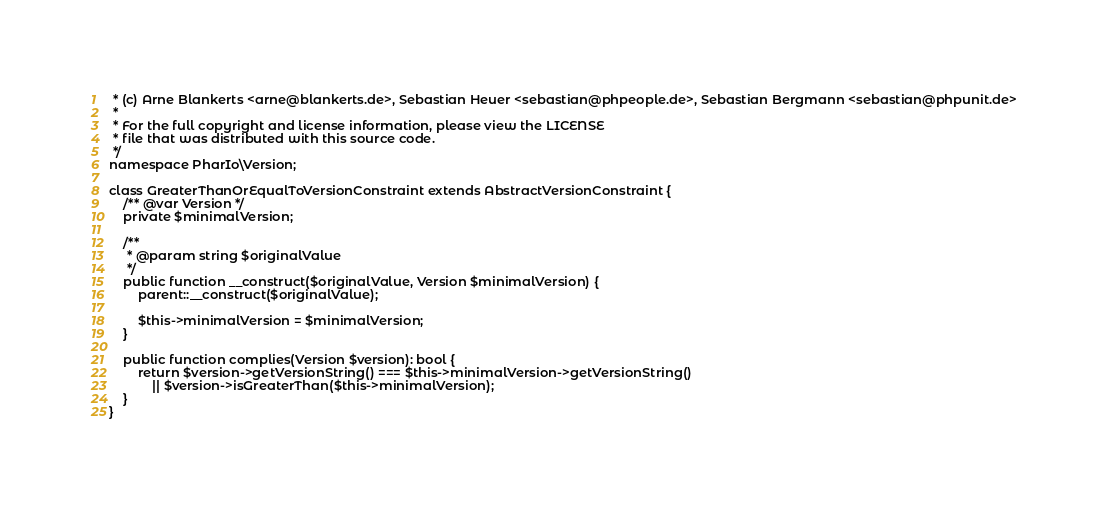<code> <loc_0><loc_0><loc_500><loc_500><_PHP_> * (c) Arne Blankerts <arne@blankerts.de>, Sebastian Heuer <sebastian@phpeople.de>, Sebastian Bergmann <sebastian@phpunit.de>
 *
 * For the full copyright and license information, please view the LICENSE
 * file that was distributed with this source code.
 */
namespace PharIo\Version;

class GreaterThanOrEqualToVersionConstraint extends AbstractVersionConstraint {
    /** @var Version */
    private $minimalVersion;

    /**
     * @param string $originalValue
     */
    public function __construct($originalValue, Version $minimalVersion) {
        parent::__construct($originalValue);

        $this->minimalVersion = $minimalVersion;
    }

    public function complies(Version $version): bool {
        return $version->getVersionString() === $this->minimalVersion->getVersionString()
            || $version->isGreaterThan($this->minimalVersion);
    }
}
</code> 